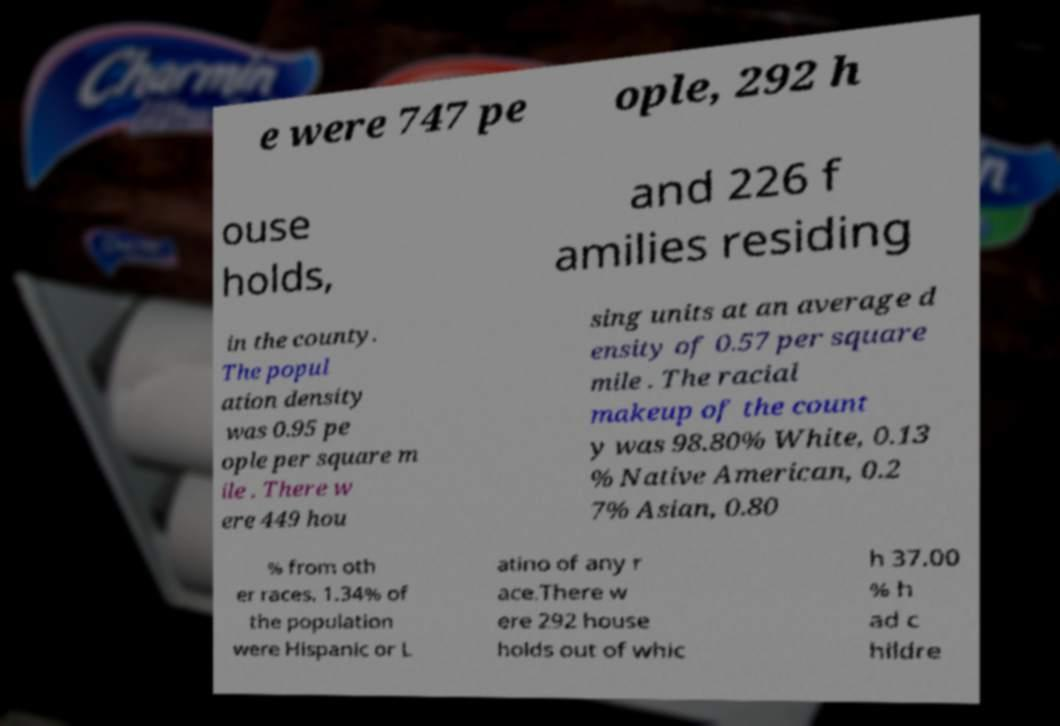Could you extract and type out the text from this image? e were 747 pe ople, 292 h ouse holds, and 226 f amilies residing in the county. The popul ation density was 0.95 pe ople per square m ile . There w ere 449 hou sing units at an average d ensity of 0.57 per square mile . The racial makeup of the count y was 98.80% White, 0.13 % Native American, 0.2 7% Asian, 0.80 % from oth er races. 1.34% of the population were Hispanic or L atino of any r ace.There w ere 292 house holds out of whic h 37.00 % h ad c hildre 